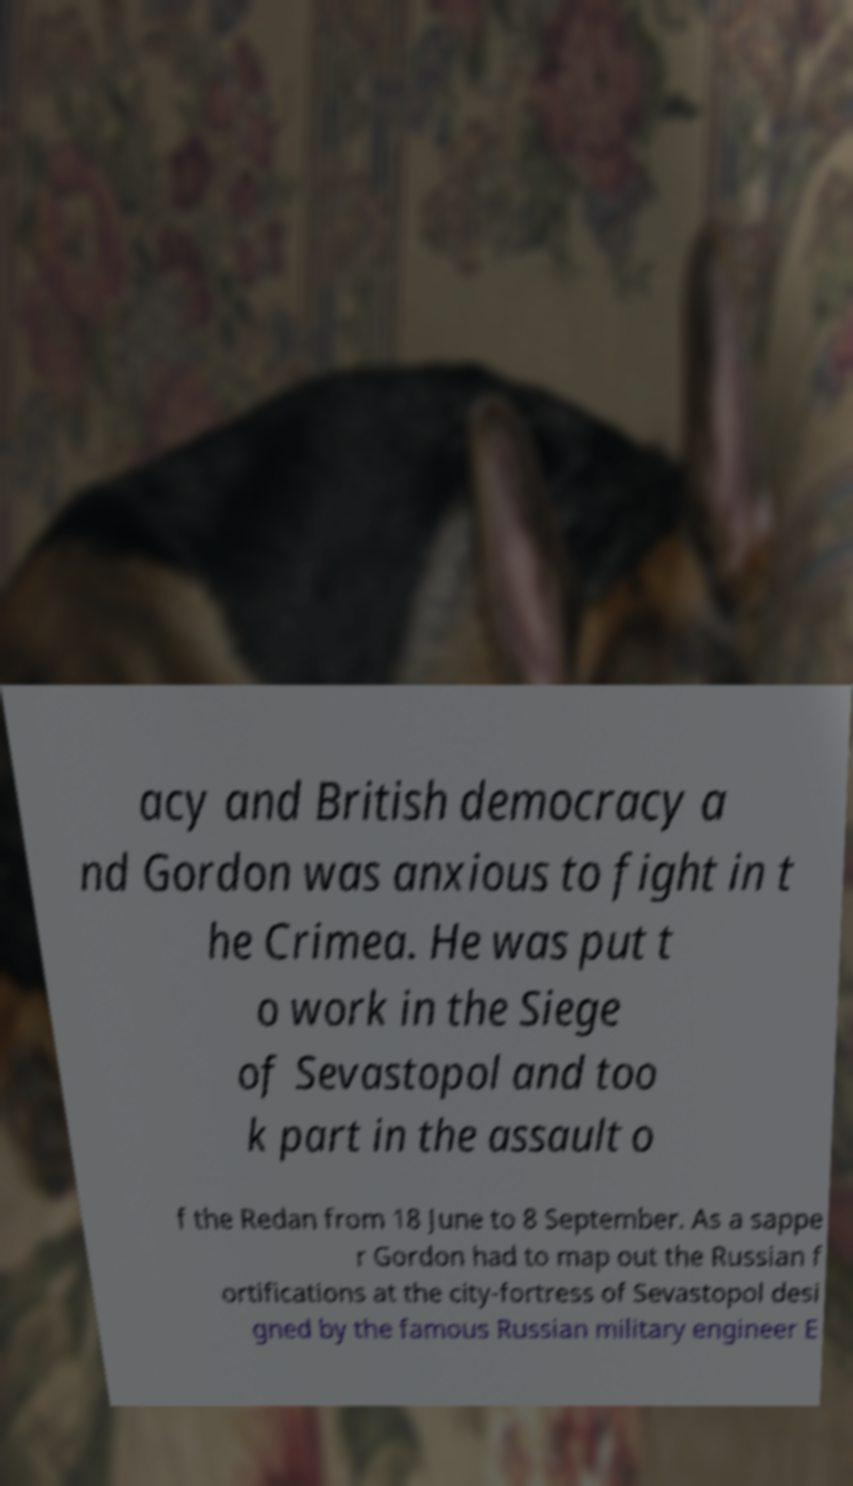Please identify and transcribe the text found in this image. acy and British democracy a nd Gordon was anxious to fight in t he Crimea. He was put t o work in the Siege of Sevastopol and too k part in the assault o f the Redan from 18 June to 8 September. As a sappe r Gordon had to map out the Russian f ortifications at the city-fortress of Sevastopol desi gned by the famous Russian military engineer E 